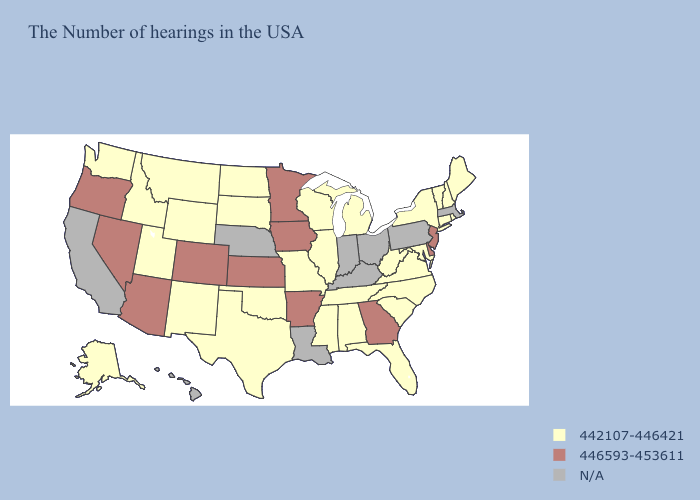Among the states that border Alabama , does Georgia have the highest value?
Give a very brief answer. Yes. Name the states that have a value in the range 446593-453611?
Answer briefly. New Jersey, Delaware, Georgia, Arkansas, Minnesota, Iowa, Kansas, Colorado, Arizona, Nevada, Oregon. What is the value of South Carolina?
Give a very brief answer. 442107-446421. Name the states that have a value in the range 442107-446421?
Keep it brief. Maine, Rhode Island, New Hampshire, Vermont, Connecticut, New York, Maryland, Virginia, North Carolina, South Carolina, West Virginia, Florida, Michigan, Alabama, Tennessee, Wisconsin, Illinois, Mississippi, Missouri, Oklahoma, Texas, South Dakota, North Dakota, Wyoming, New Mexico, Utah, Montana, Idaho, Washington, Alaska. What is the value of Montana?
Be succinct. 442107-446421. Does Alaska have the highest value in the USA?
Concise answer only. No. Among the states that border Wisconsin , does Illinois have the highest value?
Write a very short answer. No. How many symbols are there in the legend?
Concise answer only. 3. Which states have the highest value in the USA?
Answer briefly. New Jersey, Delaware, Georgia, Arkansas, Minnesota, Iowa, Kansas, Colorado, Arizona, Nevada, Oregon. What is the lowest value in states that border Utah?
Answer briefly. 442107-446421. Among the states that border Utah , does Nevada have the highest value?
Quick response, please. Yes. Which states have the lowest value in the USA?
Quick response, please. Maine, Rhode Island, New Hampshire, Vermont, Connecticut, New York, Maryland, Virginia, North Carolina, South Carolina, West Virginia, Florida, Michigan, Alabama, Tennessee, Wisconsin, Illinois, Mississippi, Missouri, Oklahoma, Texas, South Dakota, North Dakota, Wyoming, New Mexico, Utah, Montana, Idaho, Washington, Alaska. What is the value of Nebraska?
Short answer required. N/A. 